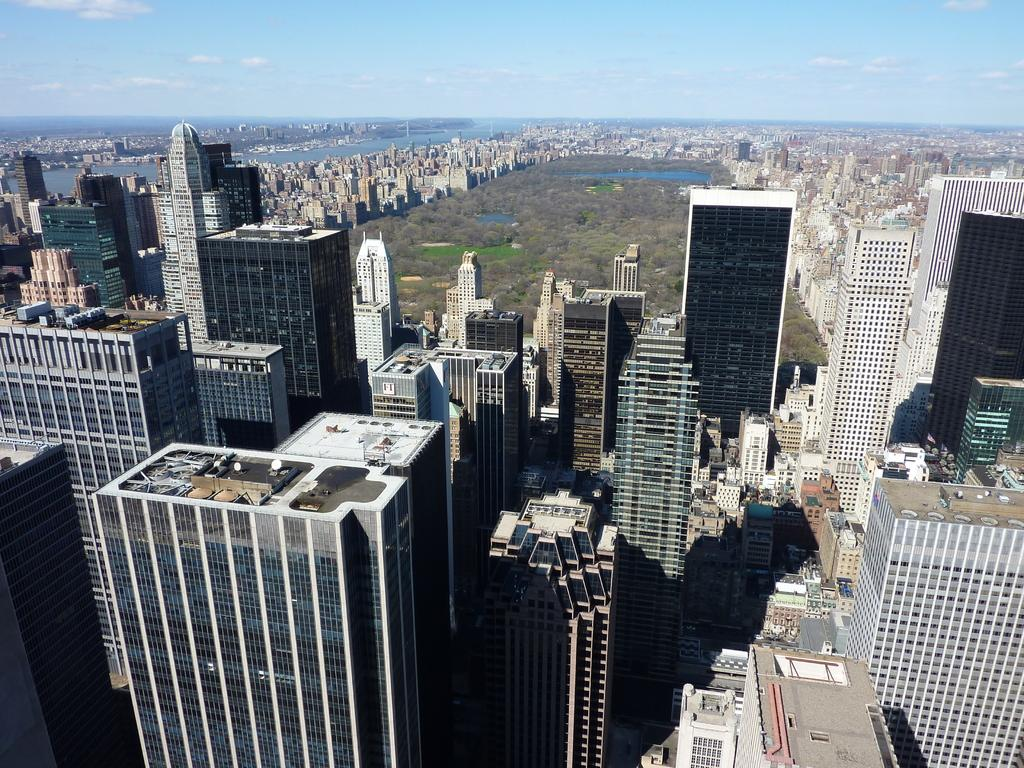What type of structures can be seen in the image? There are buildings in the image, including tower buildings. What natural elements are present in the image? There is water visible in the image, as well as trees. What can be seen in the sky in the image? There are clouds in the sky in the image. What type of sign can be seen on the water in the image? There is no sign present on the water in the image. How many tomatoes are visible in the image? There are no tomatoes present in the image. 